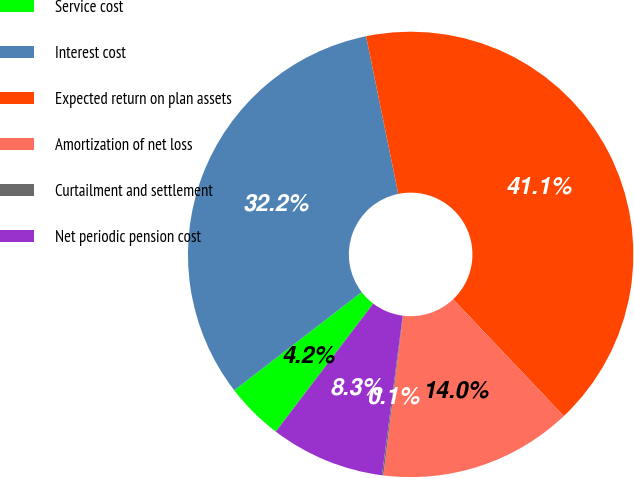<chart> <loc_0><loc_0><loc_500><loc_500><pie_chart><fcel>Service cost<fcel>Interest cost<fcel>Expected return on plan assets<fcel>Amortization of net loss<fcel>Curtailment and settlement<fcel>Net periodic pension cost<nl><fcel>4.2%<fcel>32.24%<fcel>41.14%<fcel>14.03%<fcel>0.1%<fcel>8.3%<nl></chart> 